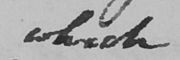Can you read and transcribe this handwriting? which 